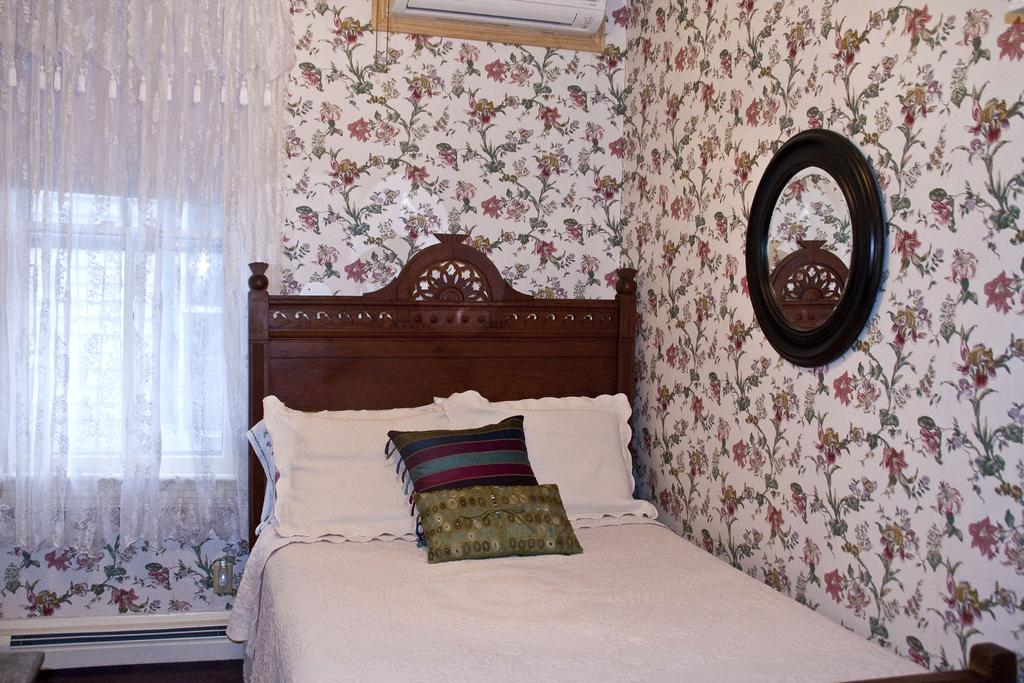What type of wall is featured in the image? There is a decorative wall in the image. What can be seen above the wall in the image? There is an air conditioner over a wall in the image. What type of window treatment is present in the image? There are white curtains in the image. What architectural feature is visible in the image? There is a window in the image. What type of furniture is present in the image? There is a bed with cushions on it in the image. How low does the unit stretch in the image? There is no unit present in the image, so it is not possible to answer this question. 